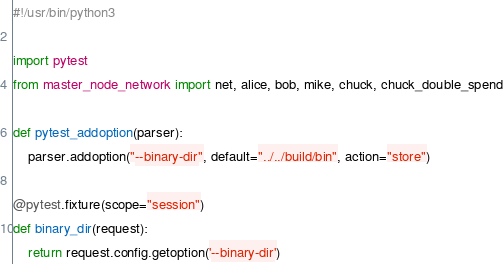Convert code to text. <code><loc_0><loc_0><loc_500><loc_500><_Python_>#!/usr/bin/python3

import pytest
from master_node_network import net, alice, bob, mike, chuck, chuck_double_spend

def pytest_addoption(parser):
    parser.addoption("--binary-dir", default="../../build/bin", action="store")

@pytest.fixture(scope="session")
def binary_dir(request):
    return request.config.getoption('--binary-dir')
</code> 